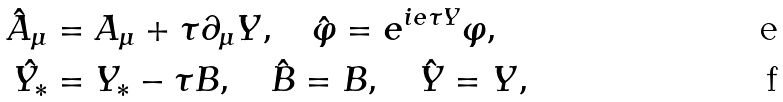Convert formula to latex. <formula><loc_0><loc_0><loc_500><loc_500>\hat { A } _ { \mu } & = A _ { \mu } + \tau \partial _ { \mu } Y , \quad \hat { \varphi } = e ^ { i e \tau Y } \varphi , \\ \hat { Y _ { * } } & = Y _ { * } - \tau B , \quad \hat { B } = B , \quad \hat { Y } = Y ,</formula> 